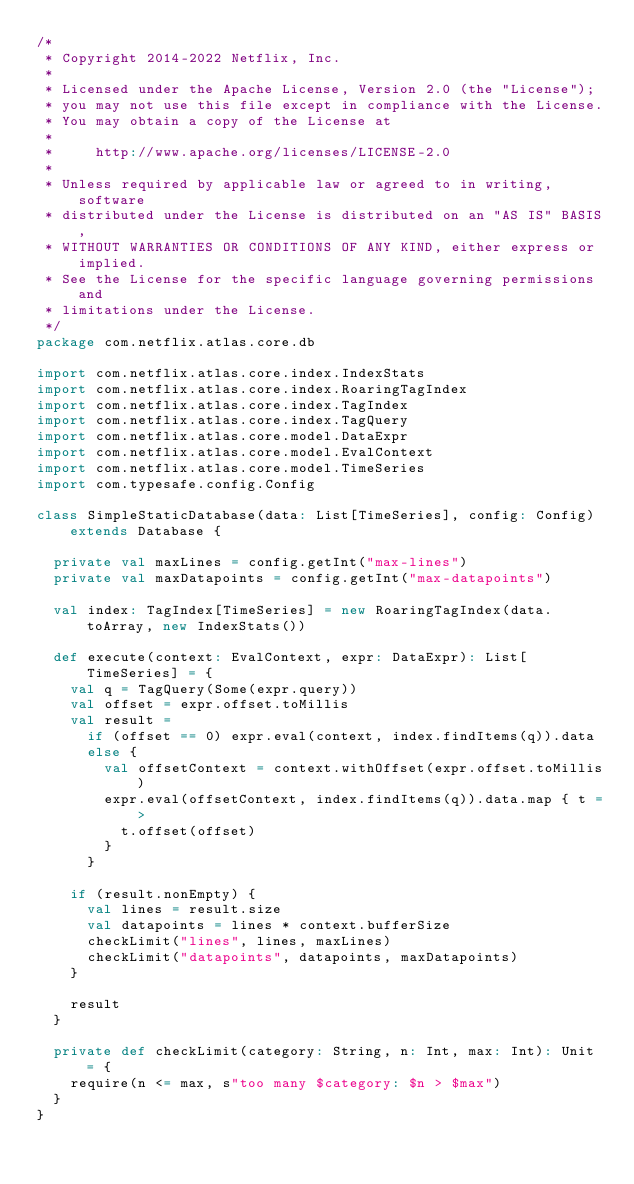Convert code to text. <code><loc_0><loc_0><loc_500><loc_500><_Scala_>/*
 * Copyright 2014-2022 Netflix, Inc.
 *
 * Licensed under the Apache License, Version 2.0 (the "License");
 * you may not use this file except in compliance with the License.
 * You may obtain a copy of the License at
 *
 *     http://www.apache.org/licenses/LICENSE-2.0
 *
 * Unless required by applicable law or agreed to in writing, software
 * distributed under the License is distributed on an "AS IS" BASIS,
 * WITHOUT WARRANTIES OR CONDITIONS OF ANY KIND, either express or implied.
 * See the License for the specific language governing permissions and
 * limitations under the License.
 */
package com.netflix.atlas.core.db

import com.netflix.atlas.core.index.IndexStats
import com.netflix.atlas.core.index.RoaringTagIndex
import com.netflix.atlas.core.index.TagIndex
import com.netflix.atlas.core.index.TagQuery
import com.netflix.atlas.core.model.DataExpr
import com.netflix.atlas.core.model.EvalContext
import com.netflix.atlas.core.model.TimeSeries
import com.typesafe.config.Config

class SimpleStaticDatabase(data: List[TimeSeries], config: Config) extends Database {

  private val maxLines = config.getInt("max-lines")
  private val maxDatapoints = config.getInt("max-datapoints")

  val index: TagIndex[TimeSeries] = new RoaringTagIndex(data.toArray, new IndexStats())

  def execute(context: EvalContext, expr: DataExpr): List[TimeSeries] = {
    val q = TagQuery(Some(expr.query))
    val offset = expr.offset.toMillis
    val result =
      if (offset == 0) expr.eval(context, index.findItems(q)).data
      else {
        val offsetContext = context.withOffset(expr.offset.toMillis)
        expr.eval(offsetContext, index.findItems(q)).data.map { t =>
          t.offset(offset)
        }
      }

    if (result.nonEmpty) {
      val lines = result.size
      val datapoints = lines * context.bufferSize
      checkLimit("lines", lines, maxLines)
      checkLimit("datapoints", datapoints, maxDatapoints)
    }

    result
  }

  private def checkLimit(category: String, n: Int, max: Int): Unit = {
    require(n <= max, s"too many $category: $n > $max")
  }
}
</code> 